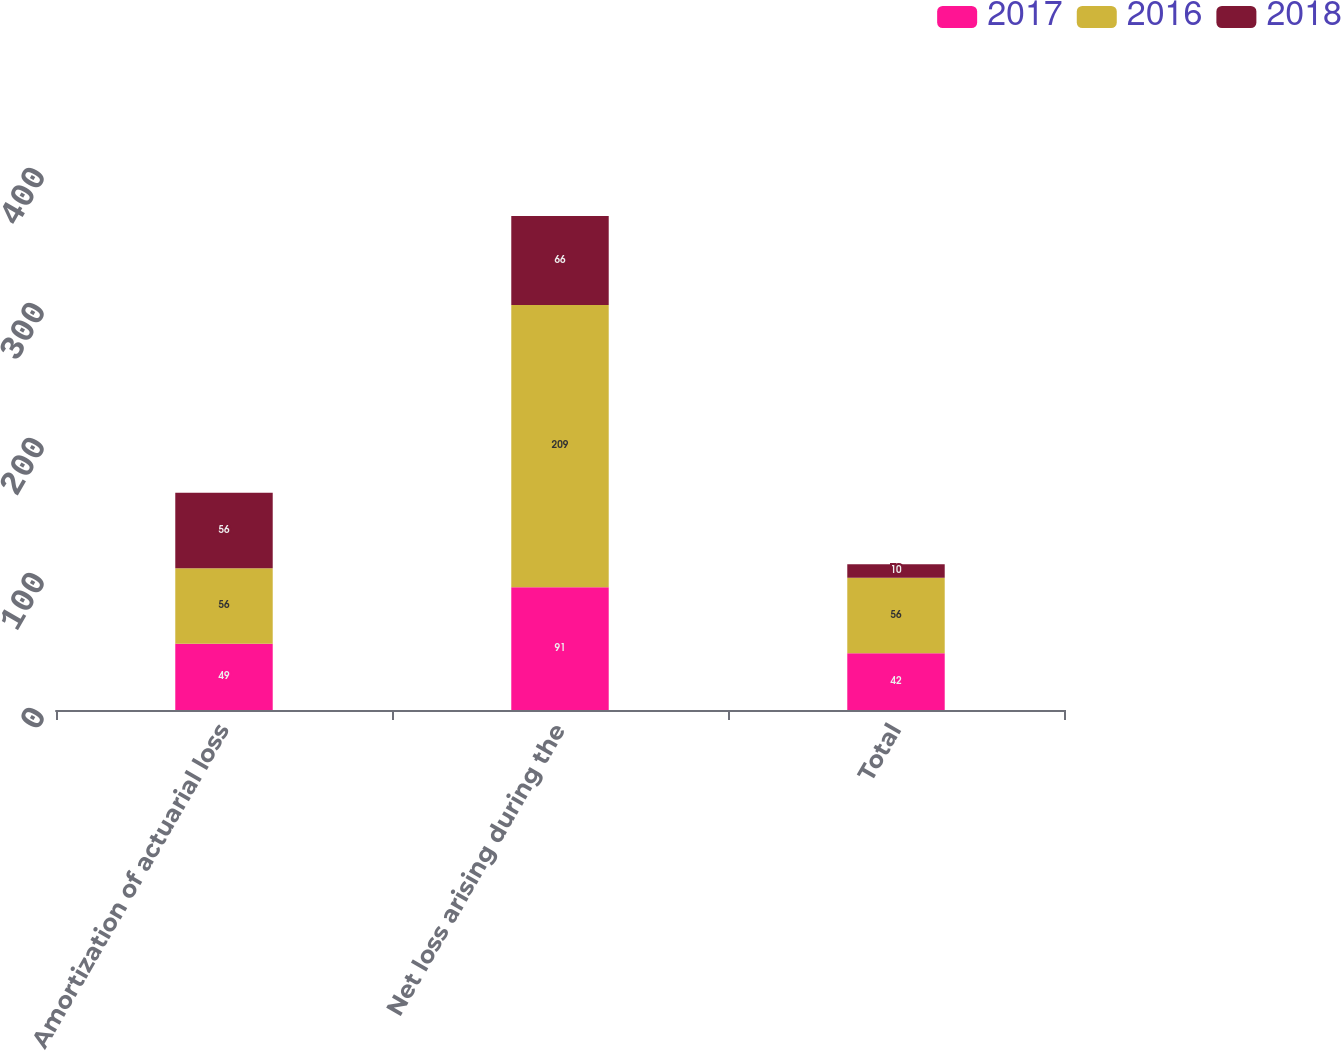<chart> <loc_0><loc_0><loc_500><loc_500><stacked_bar_chart><ecel><fcel>Amortization of actuarial loss<fcel>Net loss arising during the<fcel>Total<nl><fcel>2017<fcel>49<fcel>91<fcel>42<nl><fcel>2016<fcel>56<fcel>209<fcel>56<nl><fcel>2018<fcel>56<fcel>66<fcel>10<nl></chart> 